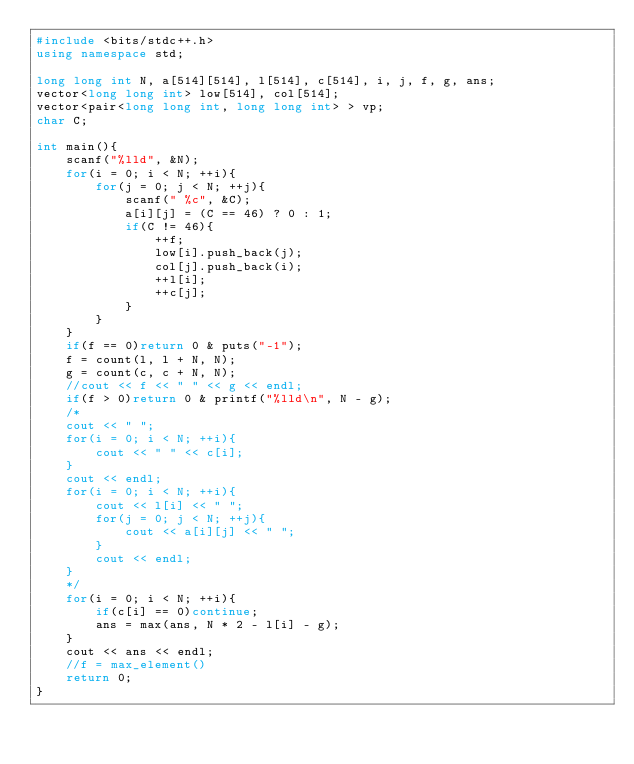<code> <loc_0><loc_0><loc_500><loc_500><_C++_>#include <bits/stdc++.h>
using namespace std;

long long int N, a[514][514], l[514], c[514], i, j, f, g, ans;
vector<long long int> low[514], col[514];
vector<pair<long long int, long long int> > vp;
char C;

int main(){
    scanf("%lld", &N);
    for(i = 0; i < N; ++i){
        for(j = 0; j < N; ++j){
            scanf(" %c", &C);
            a[i][j] = (C == 46) ? 0 : 1;
            if(C != 46){
                ++f;
                low[i].push_back(j);
                col[j].push_back(i);
                ++l[i];
                ++c[j];
            }
        }
    }
    if(f == 0)return 0 & puts("-1");
    f = count(l, l + N, N);
    g = count(c, c + N, N);
    //cout << f << " " << g << endl;
    if(f > 0)return 0 & printf("%lld\n", N - g);
    /*
    cout << " ";
    for(i = 0; i < N; ++i){
        cout << " " << c[i];
    }
    cout << endl;
    for(i = 0; i < N; ++i){
        cout << l[i] << " ";
        for(j = 0; j < N; ++j){
            cout << a[i][j] << " ";
        }
        cout << endl;
    }
    */
    for(i = 0; i < N; ++i){
        if(c[i] == 0)continue;
        ans = max(ans, N * 2 - l[i] - g);
    }
    cout << ans << endl;
    //f = max_element()
    return 0;
}
</code> 